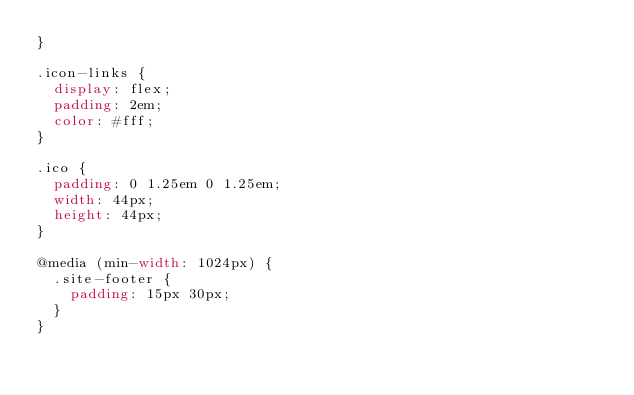Convert code to text. <code><loc_0><loc_0><loc_500><loc_500><_CSS_>}

.icon-links {
  display: flex;
  padding: 2em;
  color: #fff;
}

.ico {
  padding: 0 1.25em 0 1.25em;
  width: 44px;
  height: 44px;
}

@media (min-width: 1024px) {
  .site-footer {
    padding: 15px 30px;
  }
}
</code> 